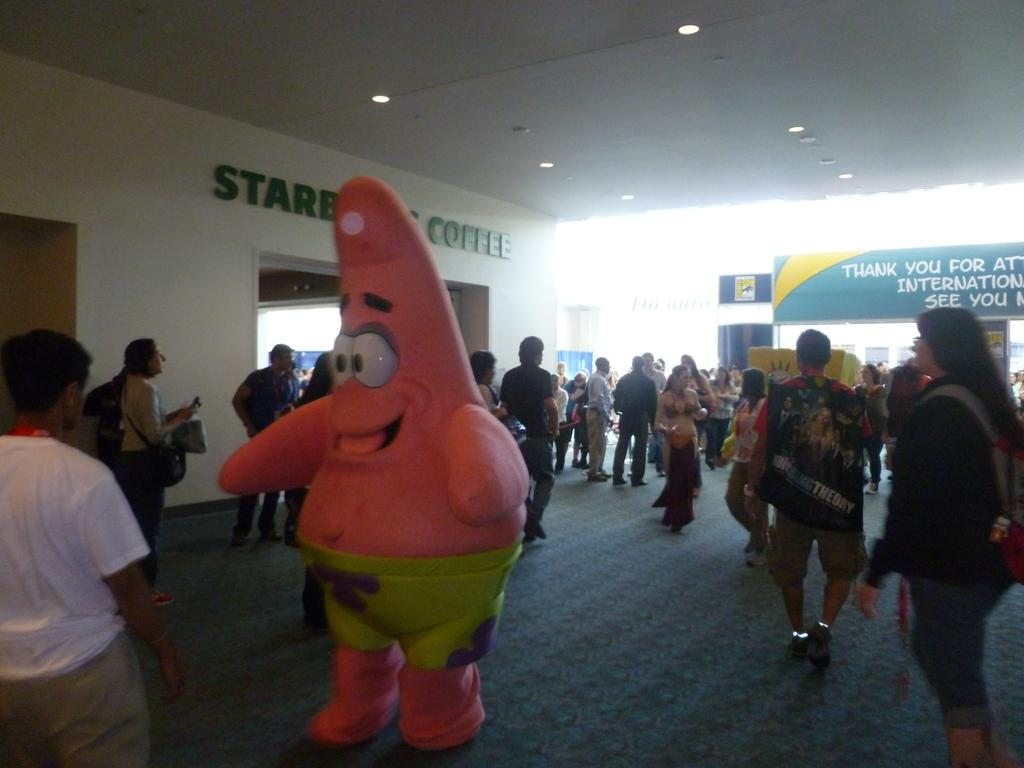What is the main subject of the image? There is a clown in the image. What can be seen in the background of the image? There are people and banners in the background of the image. What is visible at the top of the image? Lights are visible at the top of the image. What type of rhythm can be heard coming from the art in the image? There is no art present in the image, and therefore no rhythm can be heard. 